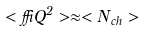<formula> <loc_0><loc_0><loc_500><loc_500>< \delta Q ^ { 2 } > \approx < N _ { c h } ></formula> 